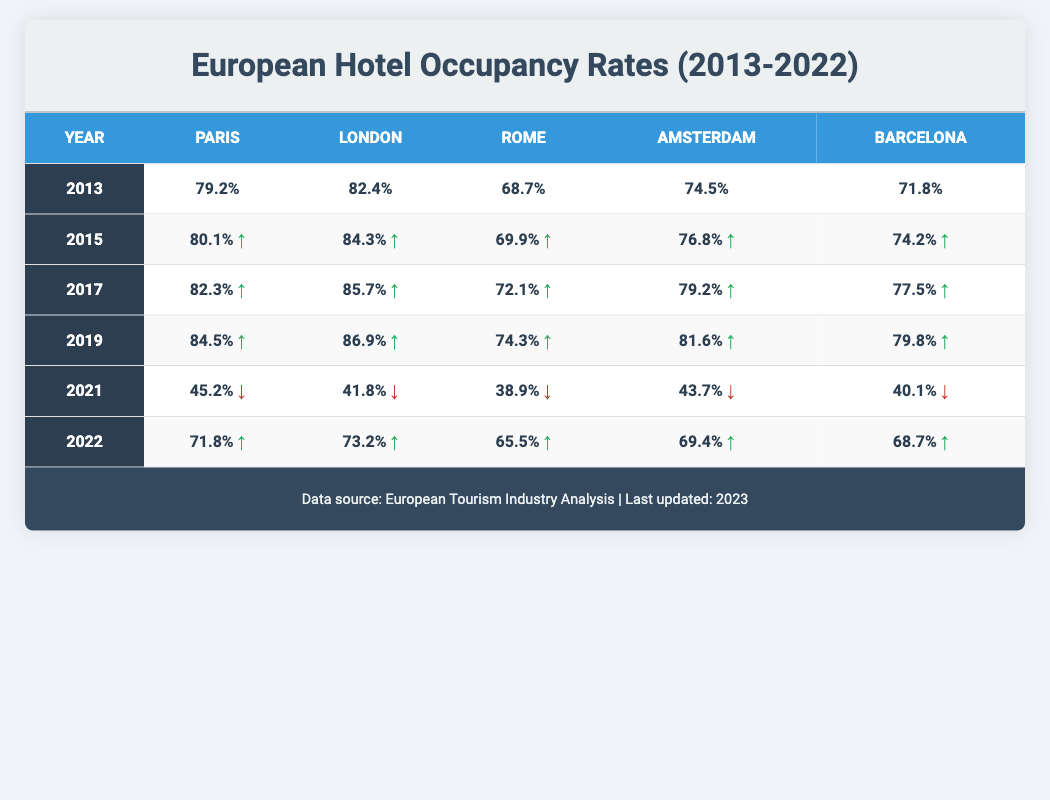What was the hotel occupancy rate in Paris in 2019? The table shows the occupancy rate for Paris in 2019, which is specifically listed. According to the table, it is 84.5%.
Answer: 84.5% What was the trend in hotel occupancy rates for London from 2013 to 2022? By examining the London occupancy rates over the years: 2013 was 82.4%, increasing to 86.9% in 2019, then dropping to 41.8% in 2021, and recovering to 73.2% in 2022. The trend shows a general increase until 2019, a significant decline in 2021, and a moderate recovery in 2022.
Answer: Initially increasing, then a sharp decline, followed by recovery What was the average hotel occupancy rate in Amsterdam from 2013 to 2022? The values for Amsterdam are: 74.5% (2013), 76.8% (2015), 79.2% (2017), 81.6% (2019), 43.7% (2021), and 69.4% (2022). Adding these rates gives 74.5 + 76.8 + 79.2 + 81.6 + 43.7 + 69.4 = 425.2. Dividing by 6 (the number of years), the average is 425.2 / 6 ≈ 70.87%.
Answer: Approximately 70.87% Did the hotel occupancy rate in Rome increase in 2022 compared to 2021? The occupancy rate for Rome in 2021 is 38.9% and in 2022 it is 65.5%. Since 65.5% is greater than 38.9%, this indicates an increase.
Answer: Yes What is the percentage difference in occupancy rates for Barcelona from 2013 to 2022? The occupancy rate for Barcelona in 2013 is 71.8% and in 2022 it is 68.7%. The difference is 71.8 - 68.7 = 3.1%. To find the percentage decrease, (3.1 / 71.8) * 100 ≈ 4.32%.
Answer: Approximately 4.32% decrease Which city had the highest occupancy rate in 2017? By checking the occupancy rates for each city in 2017 from the table: Paris 82.3%, London 85.7%, Rome 72.1%, Amsterdam 79.2%, and Barcelona 77.5%. Among these, London has the highest rate at 85.7%.
Answer: London What occupancy rates did Paris experience in 2021 and 2022? The table shows Paris' occupancy rates: 45.2% in 2021 and 71.8% in 2022, indicating a recovery from the prior year's low.
Answer: 45.2% in 2021 and 71.8% in 2022 Was the year 2019 the peak year for hotel occupancy rates across all listed cities? Analyzing the rates from the table in 2019: Paris 84.5%, London 86.9%, Rome 74.3%, Amsterdam 81.6%, and Barcelona 79.8%, compared with other years, particularly 2021 which shows significant drops for all cities, indicates 2019 was indeed a peak year.
Answer: Yes 